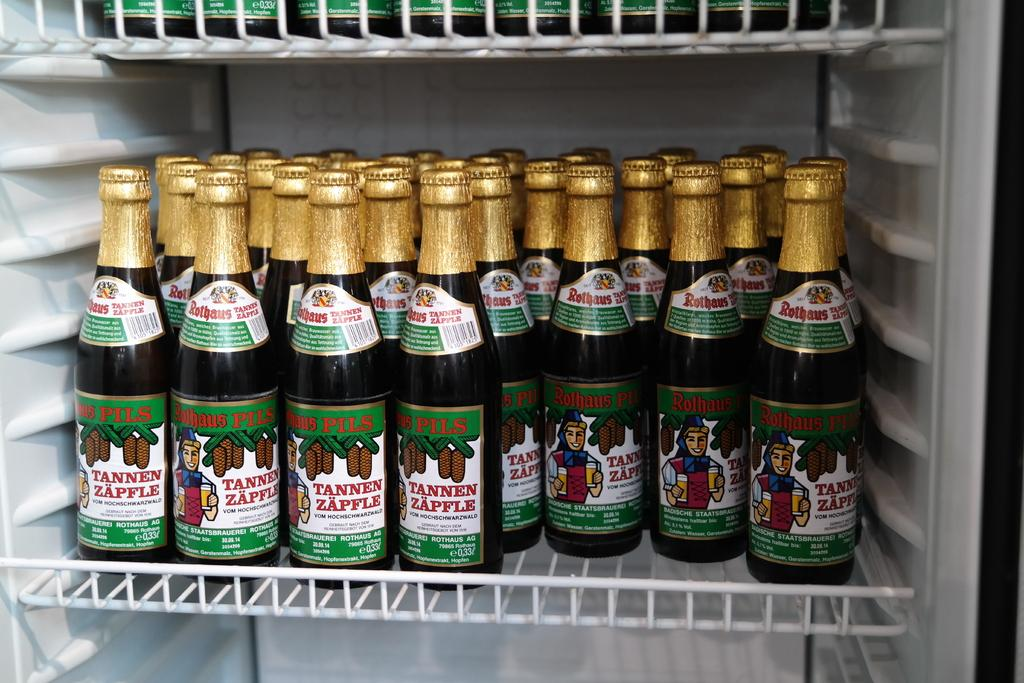<image>
Render a clear and concise summary of the photo. Many cans of Tannen Zapfle sit on the shelf of a refrigerator. 